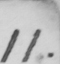Can you read and transcribe this handwriting? 11 . 